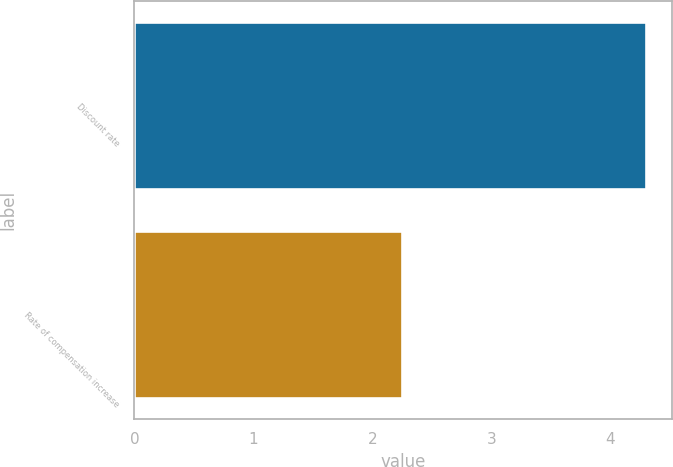Convert chart. <chart><loc_0><loc_0><loc_500><loc_500><bar_chart><fcel>Discount rate<fcel>Rate of compensation increase<nl><fcel>4.3<fcel>2.25<nl></chart> 